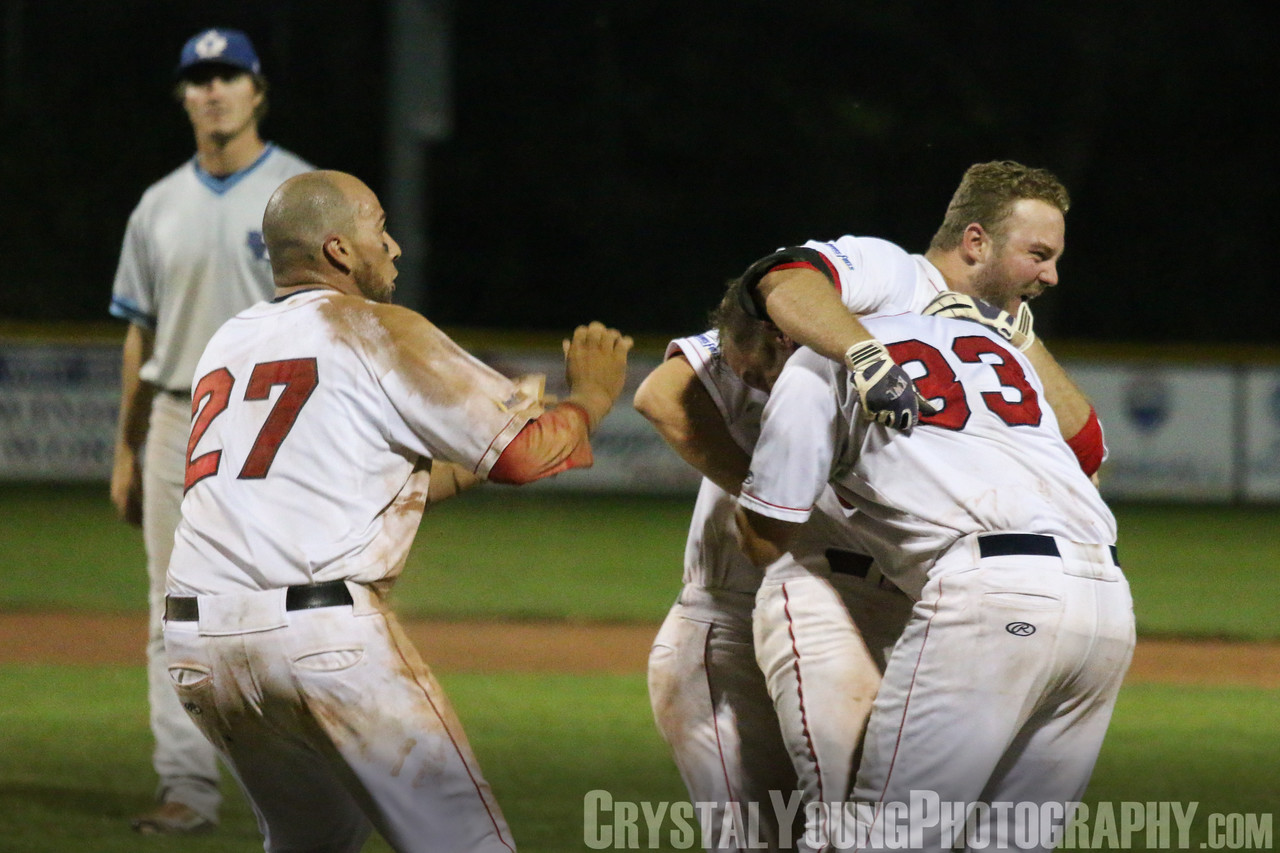What can be inferred about the outcome of the game based on the players' body language and expressions? Based on the players' body language and expressions, it is highly likely that the game ended positively for the team wearing white jerseys with red numbers. The players are celebrating with animated body language, including hugging and raising their arms, which is a strong indicator of a victorious moment or a significant successful play. Their faces display joy and excitement, suggesting they've achieved something momentous. In contrast, the player in the background, who appears to be on the opposing team, is standing alone with a downcast expression, and his posture, with hands on hips, conveys disappointment or resignation. This stark contrast in the players' expressions and body language strongly implies that his team did not win the game. 